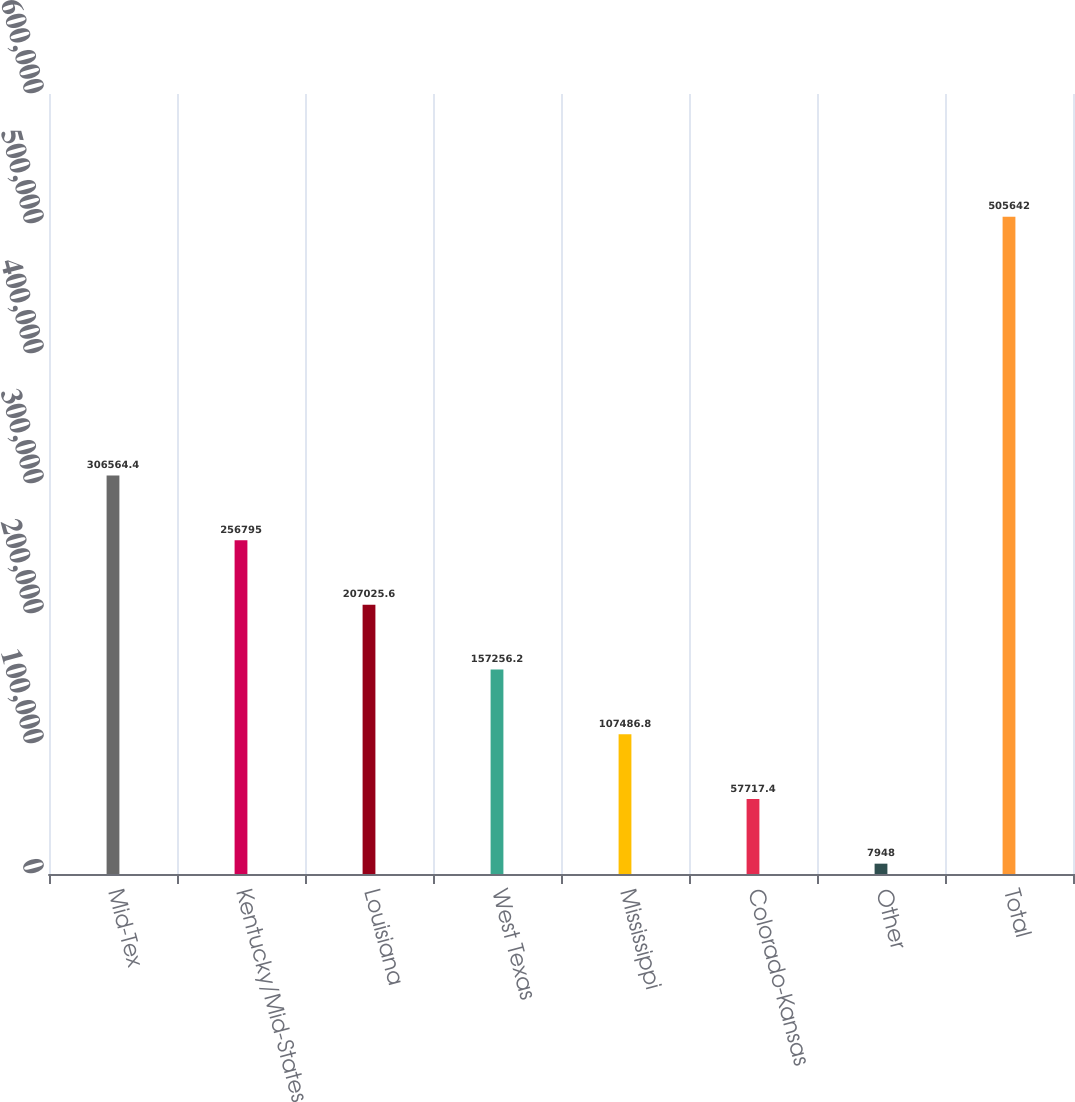<chart> <loc_0><loc_0><loc_500><loc_500><bar_chart><fcel>Mid-Tex<fcel>Kentucky/Mid-States<fcel>Louisiana<fcel>West Texas<fcel>Mississippi<fcel>Colorado-Kansas<fcel>Other<fcel>Total<nl><fcel>306564<fcel>256795<fcel>207026<fcel>157256<fcel>107487<fcel>57717.4<fcel>7948<fcel>505642<nl></chart> 